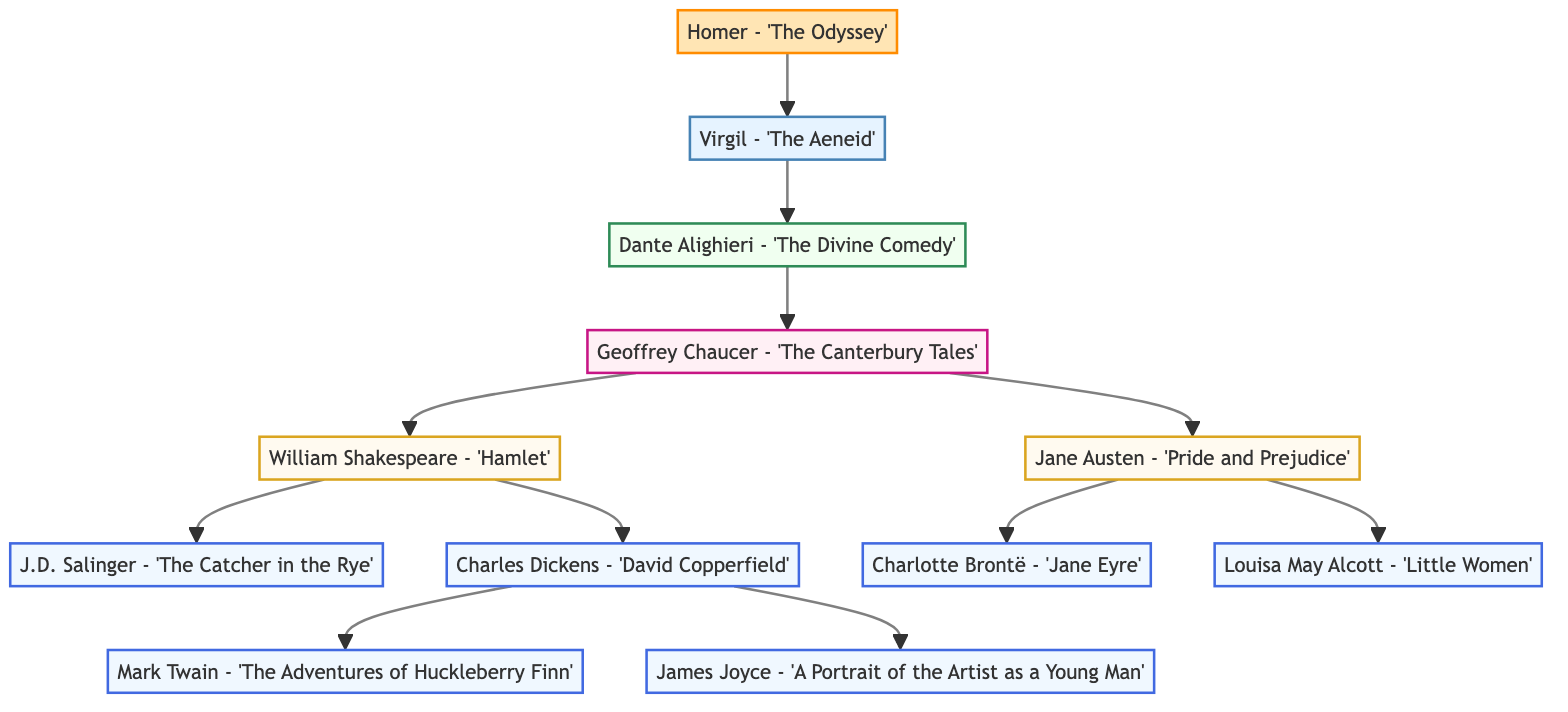What is the name of the root node? The root node of the family tree represents the main theme derived from prior literary works, which is "Literary Lineage: Tracing the Inspirations and Influences in Classical Coming-of-Age Literature."
Answer: Literary Lineage: Tracing the Inspirations and Influences in Classical Coming-of-Age Literature How many children does Geoffrey Chaucer have? Geoffrey Chaucer, as depicted in the tree, has two children, which are William Shakespeare and Jane Austen.
Answer: 2 Who is the parent of J.D. Salinger? J.D. Salinger is a child of William Shakespeare in the diagram, specifically under the work "Hamlet." This relationship shows that Salinger is influenced by Shakespeare's writings.
Answer: William Shakespeare List one of the works attributed to Charlotte Brontë. Charlotte Brontë has one notable work linked to her in this family tree: "Jane Eyre." The focus on her work reflects her contribution to coming-of-age themes in literature.
Answer: Jane Eyre Which author is positioned directly under Charles Dickens? Charles Dickens has two authors directly beneath him in the family lineage, Mark Twain and James Joyce, showcasing his impact on their writing styles and themes.
Answer: Mark Twain How deep is the tree? To find the depth, consider the longest branch from the root to the furthest descendant, which in this case measures five levels. This depicts how interconnected these literary influences are.
Answer: 5 What is the relationship between Dante Alighieri and Geoffrey Chaucer? Dante Alighieri is the child of Virgil, who is the child of Homer, leading to Geoffrey Chaucer. This relationship demonstrates a direct literary influence from Homer to Chaucer through Alighieri.
Answer: Grandparent-grandchild How many levels are represented in the diagram? The diagram can be analyzed based on the various hierarchical stages representing influences and inspirations. There are five distinct levels observed in this family tree.
Answer: 5 Which work is directly connected to William Shakespeare? Directly connected to William Shakespeare, as illustrated in the diagram, is "Hamlet," which leads to J.D. Salinger and Charles Dickens underneath it.
Answer: Hamlet 